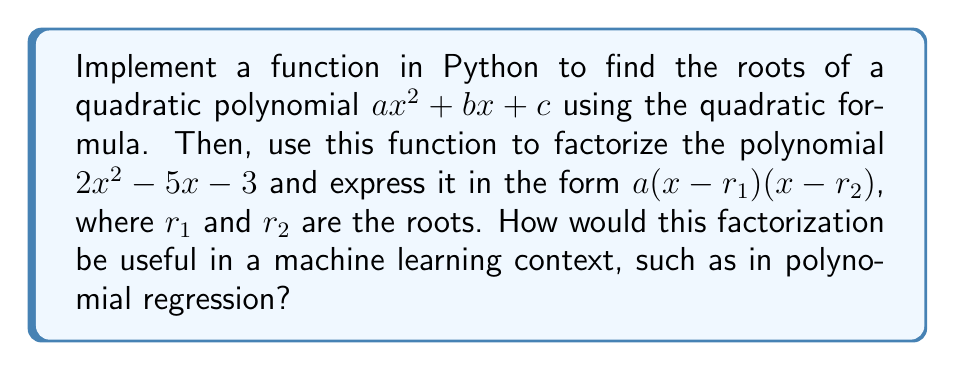Solve this math problem. To solve this problem, we'll follow these steps:

1. Implement the quadratic formula function:
   The quadratic formula is given by:
   
   $$x = \frac{-b \pm \sqrt{b^2 - 4ac}}{2a}$$

   Python implementation:

   ```python
   import math

   def quadratic_roots(a, b, c):
       discriminant = b**2 - 4*a*c
       if discriminant < 0:
           return None  # No real roots
       elif discriminant == 0:
           root = -b / (2*a)
           return (root, root)
       else:
           root1 = (-b + math.sqrt(discriminant)) / (2*a)
           root2 = (-b - math.sqrt(discriminant)) / (2*a)
           return (root1, root2)
   ```

2. Use the function to find the roots of $2x^2 - 5x - 3$:
   
   ```python
   roots = quadratic_roots(2, -5, -3)
   print(roots)
   ```

   This will output approximately (3.0, -0.5).

3. Express the polynomial in factored form:
   Given the roots $r_1 = 3$ and $r_2 = -0.5$, we can express the polynomial as:
   
   $$2(x-3)(x+0.5)$$

4. Usefulness in machine learning context:
   In polynomial regression, we often deal with high-degree polynomials. Factorization can be useful for:
   
   a) Feature engineering: By identifying the roots, we can create new features based on the distance from these roots, potentially improving the model's performance.
   
   b) Model interpretability: Factored form can provide insights into the behavior of the polynomial, making it easier to understand the relationship between variables.
   
   c) Numerical stability: Working with factored polynomials can improve numerical stability in some algorithms, especially when dealing with high-degree polynomials.
   
   d) Dimensionality reduction: In some cases, factorization can help identify redundant terms, allowing for simplification of the model.
Answer: The factored form of $2x^2 - 5x - 3$ is $2(x-3)(x+0.5)$. In a machine learning context, this factorization can be useful for feature engineering, improving model interpretability, enhancing numerical stability, and potentially aiding in dimensionality reduction for polynomial regression models. 